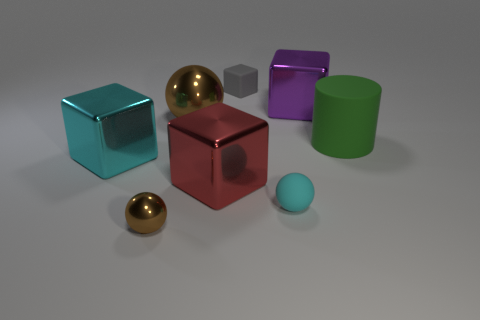Subtract all brown spheres. How many were subtracted if there are1brown spheres left? 1 Subtract all cyan balls. Subtract all blue cubes. How many balls are left? 2 Add 1 small brown shiny spheres. How many objects exist? 9 Subtract all balls. How many objects are left? 5 Add 1 brown shiny spheres. How many brown shiny spheres exist? 3 Subtract 1 cyan spheres. How many objects are left? 7 Subtract all cyan balls. Subtract all tiny cyan rubber balls. How many objects are left? 6 Add 5 large red objects. How many large red objects are left? 6 